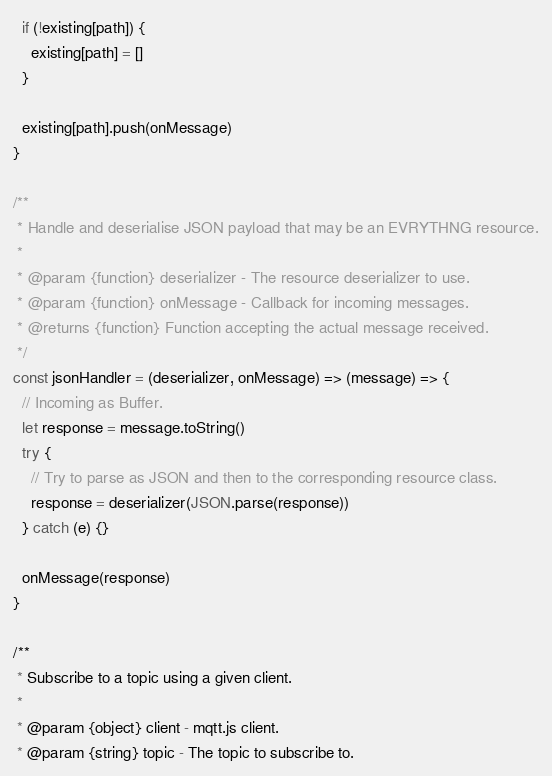Convert code to text. <code><loc_0><loc_0><loc_500><loc_500><_JavaScript_>  if (!existing[path]) {
    existing[path] = []
  }

  existing[path].push(onMessage)
}

/**
 * Handle and deserialise JSON payload that may be an EVRYTHNG resource.
 *
 * @param {function} deserializer - The resource deserializer to use.
 * @param {function} onMessage - Callback for incoming messages.
 * @returns {function} Function accepting the actual message received.
 */
const jsonHandler = (deserializer, onMessage) => (message) => {
  // Incoming as Buffer.
  let response = message.toString()
  try {
    // Try to parse as JSON and then to the corresponding resource class.
    response = deserializer(JSON.parse(response))
  } catch (e) {}

  onMessage(response)
}

/**
 * Subscribe to a topic using a given client.
 *
 * @param {object} client - mqtt.js client.
 * @param {string} topic - The topic to subscribe to.</code> 